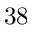Convert formula to latex. <formula><loc_0><loc_0><loc_500><loc_500>3 8</formula> 